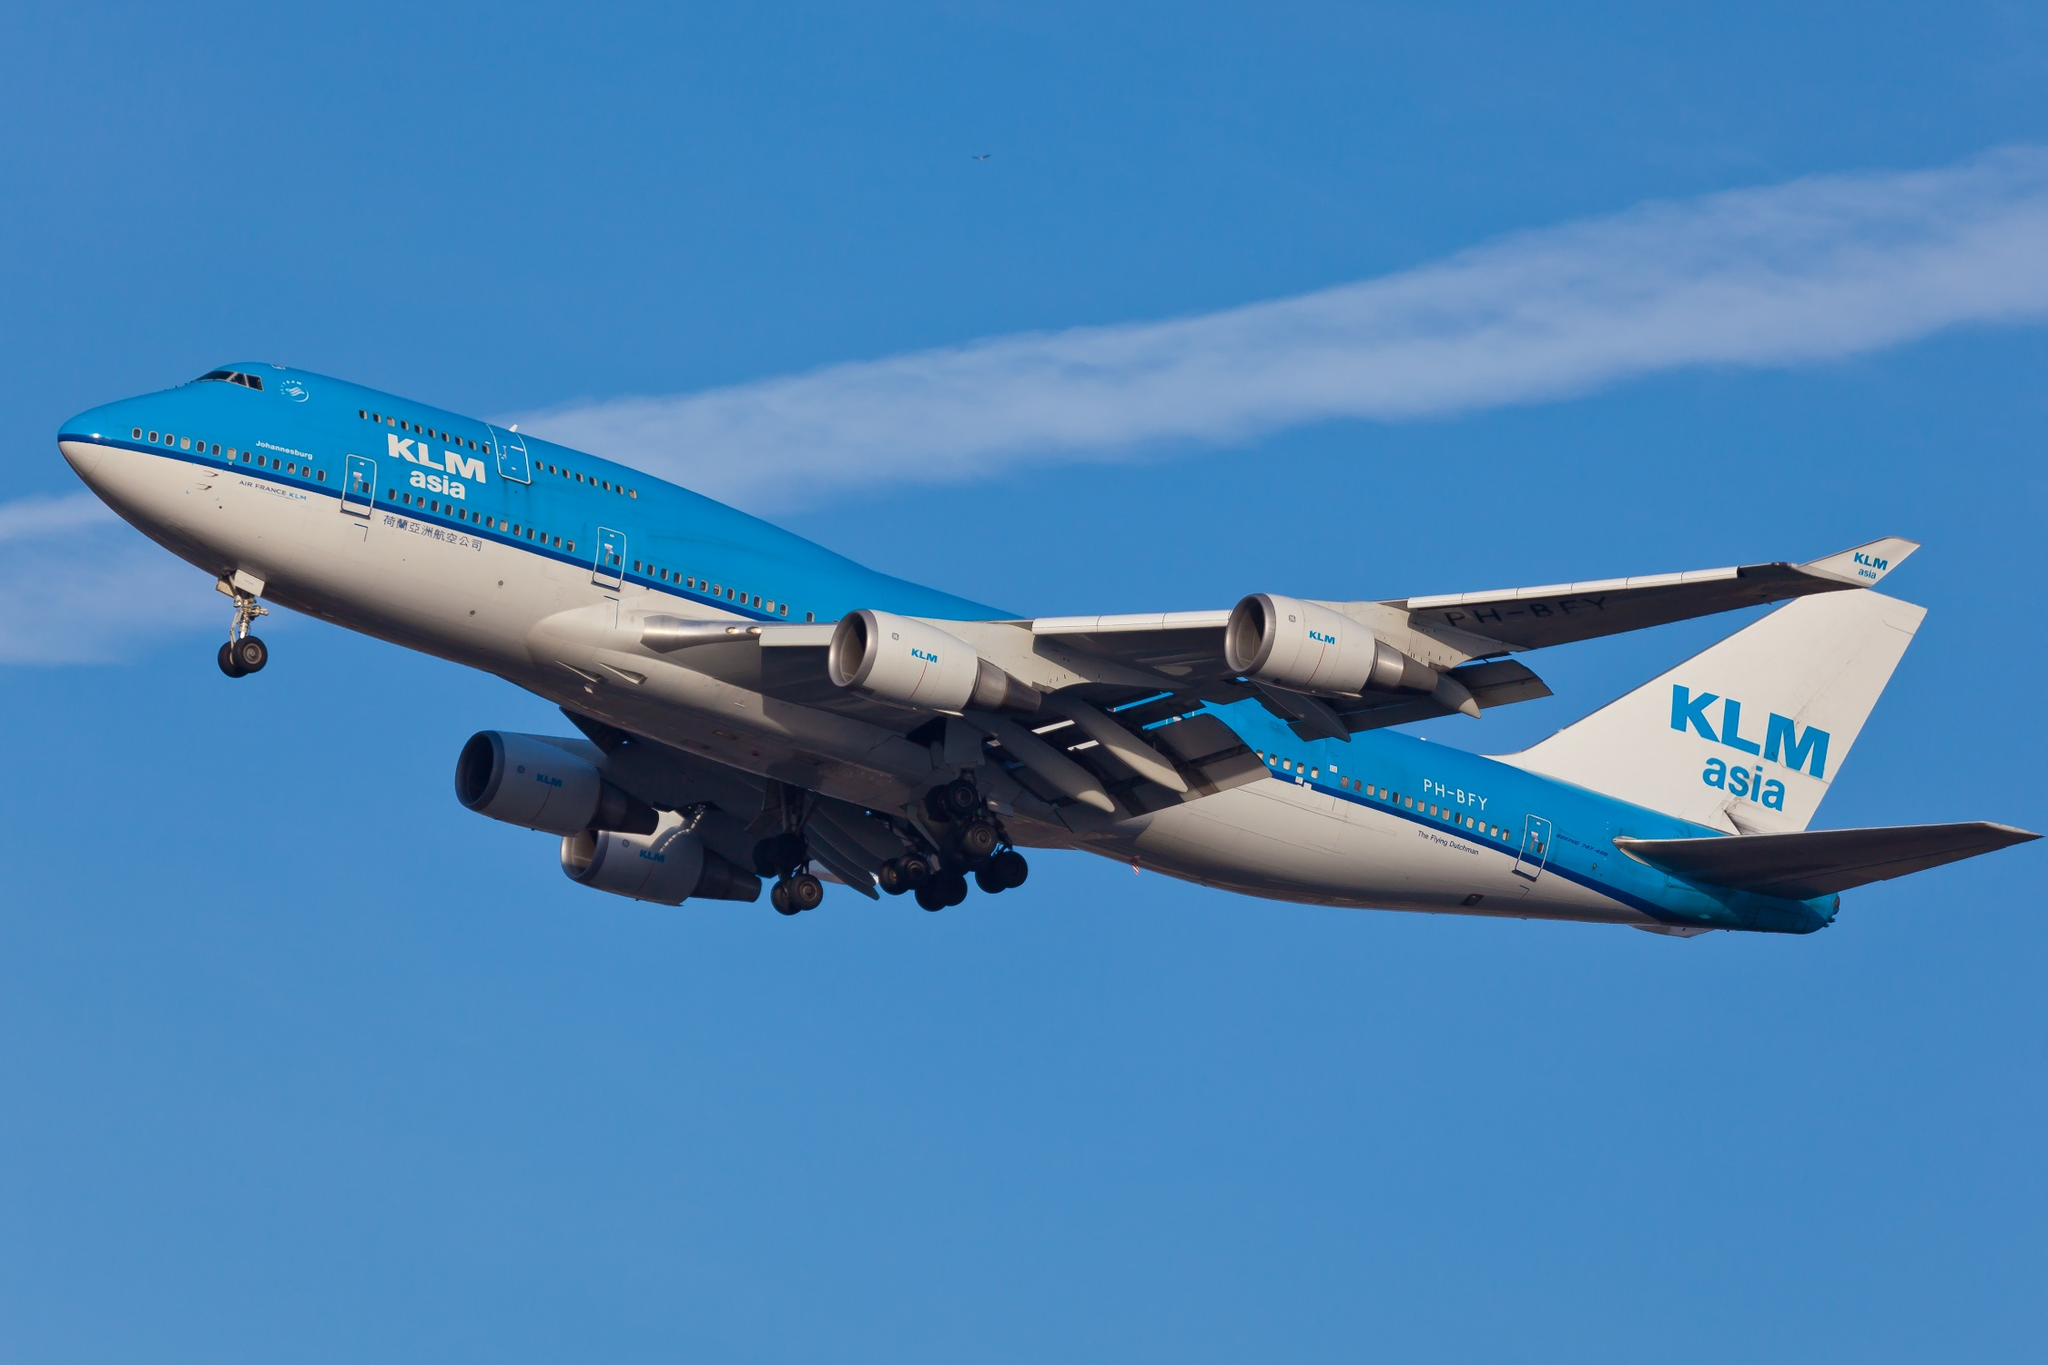What are the key elements in this picture? The picture features a KLM Asia Boeing 747-400 aircraft in flight, distinguishable by its prominent blue and white color scheme and the 'KLM Asia' logo on the tail. The aircraft is captured from its starboard side, slightly banking towards the viewer, which highlights the undercarriage and the four powerful engines attached to its wings. The clean and vast blue sky in the backdrop accentuates the plane’s altitude and the clarity of a bright day conducive to flying. This image not only depicts the grandeur of the Boeing 747 but also subtly reflects on the aviation industry's reach and operational capabilities, particularly in the Asian sector. 